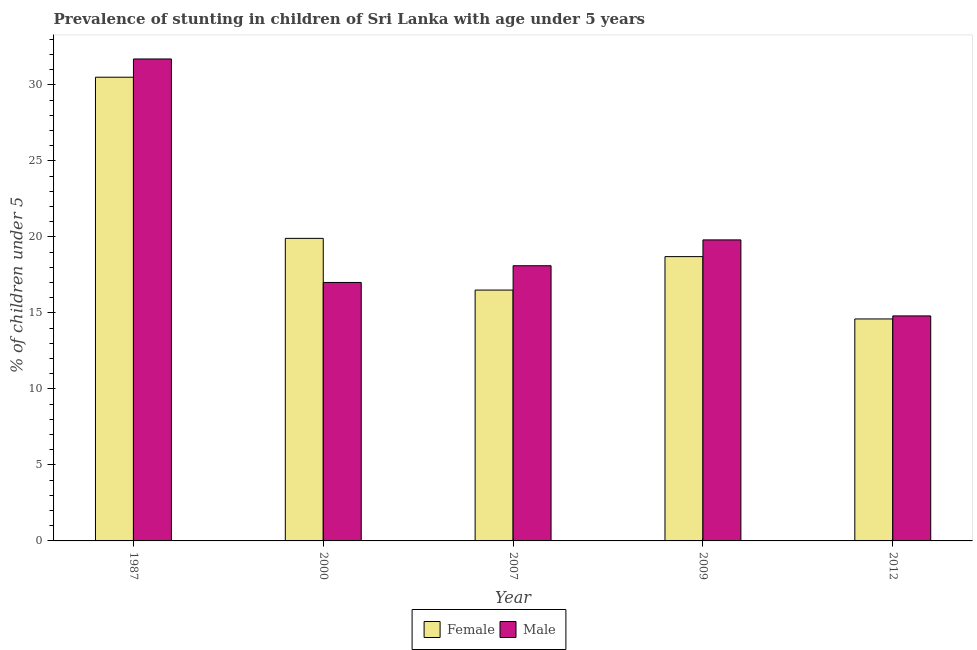How many groups of bars are there?
Offer a terse response. 5. How many bars are there on the 5th tick from the right?
Give a very brief answer. 2. In how many cases, is the number of bars for a given year not equal to the number of legend labels?
Offer a terse response. 0. Across all years, what is the maximum percentage of stunted male children?
Ensure brevity in your answer.  31.7. Across all years, what is the minimum percentage of stunted female children?
Provide a short and direct response. 14.6. In which year was the percentage of stunted male children minimum?
Your answer should be compact. 2012. What is the total percentage of stunted female children in the graph?
Make the answer very short. 100.2. What is the difference between the percentage of stunted male children in 2000 and that in 2012?
Offer a very short reply. 2.2. What is the difference between the percentage of stunted female children in 2012 and the percentage of stunted male children in 2000?
Your response must be concise. -5.3. What is the average percentage of stunted female children per year?
Your answer should be compact. 20.04. In the year 1987, what is the difference between the percentage of stunted male children and percentage of stunted female children?
Offer a terse response. 0. In how many years, is the percentage of stunted male children greater than 7 %?
Ensure brevity in your answer.  5. What is the ratio of the percentage of stunted male children in 2000 to that in 2007?
Make the answer very short. 0.94. Is the percentage of stunted female children in 1987 less than that in 2009?
Provide a short and direct response. No. Is the difference between the percentage of stunted female children in 1987 and 2009 greater than the difference between the percentage of stunted male children in 1987 and 2009?
Offer a very short reply. No. What is the difference between the highest and the second highest percentage of stunted male children?
Your response must be concise. 11.9. What is the difference between the highest and the lowest percentage of stunted male children?
Your response must be concise. 16.9. What does the 2nd bar from the left in 2009 represents?
Make the answer very short. Male. Are all the bars in the graph horizontal?
Ensure brevity in your answer.  No. How many years are there in the graph?
Give a very brief answer. 5. Does the graph contain any zero values?
Provide a short and direct response. No. Where does the legend appear in the graph?
Keep it short and to the point. Bottom center. How many legend labels are there?
Your answer should be compact. 2. What is the title of the graph?
Your answer should be compact. Prevalence of stunting in children of Sri Lanka with age under 5 years. What is the label or title of the X-axis?
Give a very brief answer. Year. What is the label or title of the Y-axis?
Your answer should be compact.  % of children under 5. What is the  % of children under 5 in Female in 1987?
Keep it short and to the point. 30.5. What is the  % of children under 5 of Male in 1987?
Give a very brief answer. 31.7. What is the  % of children under 5 of Female in 2000?
Your response must be concise. 19.9. What is the  % of children under 5 in Male in 2000?
Your answer should be very brief. 17. What is the  % of children under 5 in Female in 2007?
Your answer should be very brief. 16.5. What is the  % of children under 5 in Male in 2007?
Keep it short and to the point. 18.1. What is the  % of children under 5 in Female in 2009?
Make the answer very short. 18.7. What is the  % of children under 5 in Male in 2009?
Provide a short and direct response. 19.8. What is the  % of children under 5 in Female in 2012?
Provide a succinct answer. 14.6. What is the  % of children under 5 of Male in 2012?
Provide a succinct answer. 14.8. Across all years, what is the maximum  % of children under 5 in Female?
Offer a terse response. 30.5. Across all years, what is the maximum  % of children under 5 of Male?
Give a very brief answer. 31.7. Across all years, what is the minimum  % of children under 5 of Female?
Provide a succinct answer. 14.6. Across all years, what is the minimum  % of children under 5 in Male?
Offer a very short reply. 14.8. What is the total  % of children under 5 of Female in the graph?
Your answer should be very brief. 100.2. What is the total  % of children under 5 in Male in the graph?
Ensure brevity in your answer.  101.4. What is the difference between the  % of children under 5 of Female in 1987 and that in 2000?
Provide a succinct answer. 10.6. What is the difference between the  % of children under 5 of Female in 1987 and that in 2007?
Your response must be concise. 14. What is the difference between the  % of children under 5 in Male in 1987 and that in 2007?
Make the answer very short. 13.6. What is the difference between the  % of children under 5 of Female in 1987 and that in 2009?
Your answer should be compact. 11.8. What is the difference between the  % of children under 5 of Female in 2000 and that in 2009?
Ensure brevity in your answer.  1.2. What is the difference between the  % of children under 5 in Male in 2000 and that in 2009?
Provide a short and direct response. -2.8. What is the difference between the  % of children under 5 in Female in 2000 and that in 2012?
Make the answer very short. 5.3. What is the difference between the  % of children under 5 in Male in 2000 and that in 2012?
Offer a terse response. 2.2. What is the difference between the  % of children under 5 in Male in 2007 and that in 2012?
Provide a succinct answer. 3.3. What is the difference between the  % of children under 5 in Female in 2000 and the  % of children under 5 in Male in 2007?
Keep it short and to the point. 1.8. What is the difference between the  % of children under 5 of Female in 2000 and the  % of children under 5 of Male in 2012?
Give a very brief answer. 5.1. What is the difference between the  % of children under 5 of Female in 2007 and the  % of children under 5 of Male in 2009?
Offer a very short reply. -3.3. What is the difference between the  % of children under 5 of Female in 2007 and the  % of children under 5 of Male in 2012?
Your answer should be compact. 1.7. What is the average  % of children under 5 in Female per year?
Make the answer very short. 20.04. What is the average  % of children under 5 in Male per year?
Provide a short and direct response. 20.28. In the year 2000, what is the difference between the  % of children under 5 in Female and  % of children under 5 in Male?
Make the answer very short. 2.9. In the year 2007, what is the difference between the  % of children under 5 in Female and  % of children under 5 in Male?
Give a very brief answer. -1.6. In the year 2012, what is the difference between the  % of children under 5 of Female and  % of children under 5 of Male?
Your answer should be compact. -0.2. What is the ratio of the  % of children under 5 of Female in 1987 to that in 2000?
Provide a succinct answer. 1.53. What is the ratio of the  % of children under 5 of Male in 1987 to that in 2000?
Provide a short and direct response. 1.86. What is the ratio of the  % of children under 5 in Female in 1987 to that in 2007?
Keep it short and to the point. 1.85. What is the ratio of the  % of children under 5 of Male in 1987 to that in 2007?
Provide a short and direct response. 1.75. What is the ratio of the  % of children under 5 in Female in 1987 to that in 2009?
Keep it short and to the point. 1.63. What is the ratio of the  % of children under 5 of Male in 1987 to that in 2009?
Provide a short and direct response. 1.6. What is the ratio of the  % of children under 5 of Female in 1987 to that in 2012?
Keep it short and to the point. 2.09. What is the ratio of the  % of children under 5 in Male in 1987 to that in 2012?
Provide a succinct answer. 2.14. What is the ratio of the  % of children under 5 in Female in 2000 to that in 2007?
Keep it short and to the point. 1.21. What is the ratio of the  % of children under 5 in Male in 2000 to that in 2007?
Provide a short and direct response. 0.94. What is the ratio of the  % of children under 5 of Female in 2000 to that in 2009?
Ensure brevity in your answer.  1.06. What is the ratio of the  % of children under 5 in Male in 2000 to that in 2009?
Offer a very short reply. 0.86. What is the ratio of the  % of children under 5 in Female in 2000 to that in 2012?
Your answer should be very brief. 1.36. What is the ratio of the  % of children under 5 in Male in 2000 to that in 2012?
Provide a succinct answer. 1.15. What is the ratio of the  % of children under 5 of Female in 2007 to that in 2009?
Provide a short and direct response. 0.88. What is the ratio of the  % of children under 5 of Male in 2007 to that in 2009?
Offer a very short reply. 0.91. What is the ratio of the  % of children under 5 of Female in 2007 to that in 2012?
Your response must be concise. 1.13. What is the ratio of the  % of children under 5 of Male in 2007 to that in 2012?
Provide a short and direct response. 1.22. What is the ratio of the  % of children under 5 of Female in 2009 to that in 2012?
Provide a succinct answer. 1.28. What is the ratio of the  % of children under 5 of Male in 2009 to that in 2012?
Give a very brief answer. 1.34. What is the difference between the highest and the second highest  % of children under 5 of Female?
Ensure brevity in your answer.  10.6. What is the difference between the highest and the second highest  % of children under 5 of Male?
Your response must be concise. 11.9. What is the difference between the highest and the lowest  % of children under 5 of Female?
Make the answer very short. 15.9. 